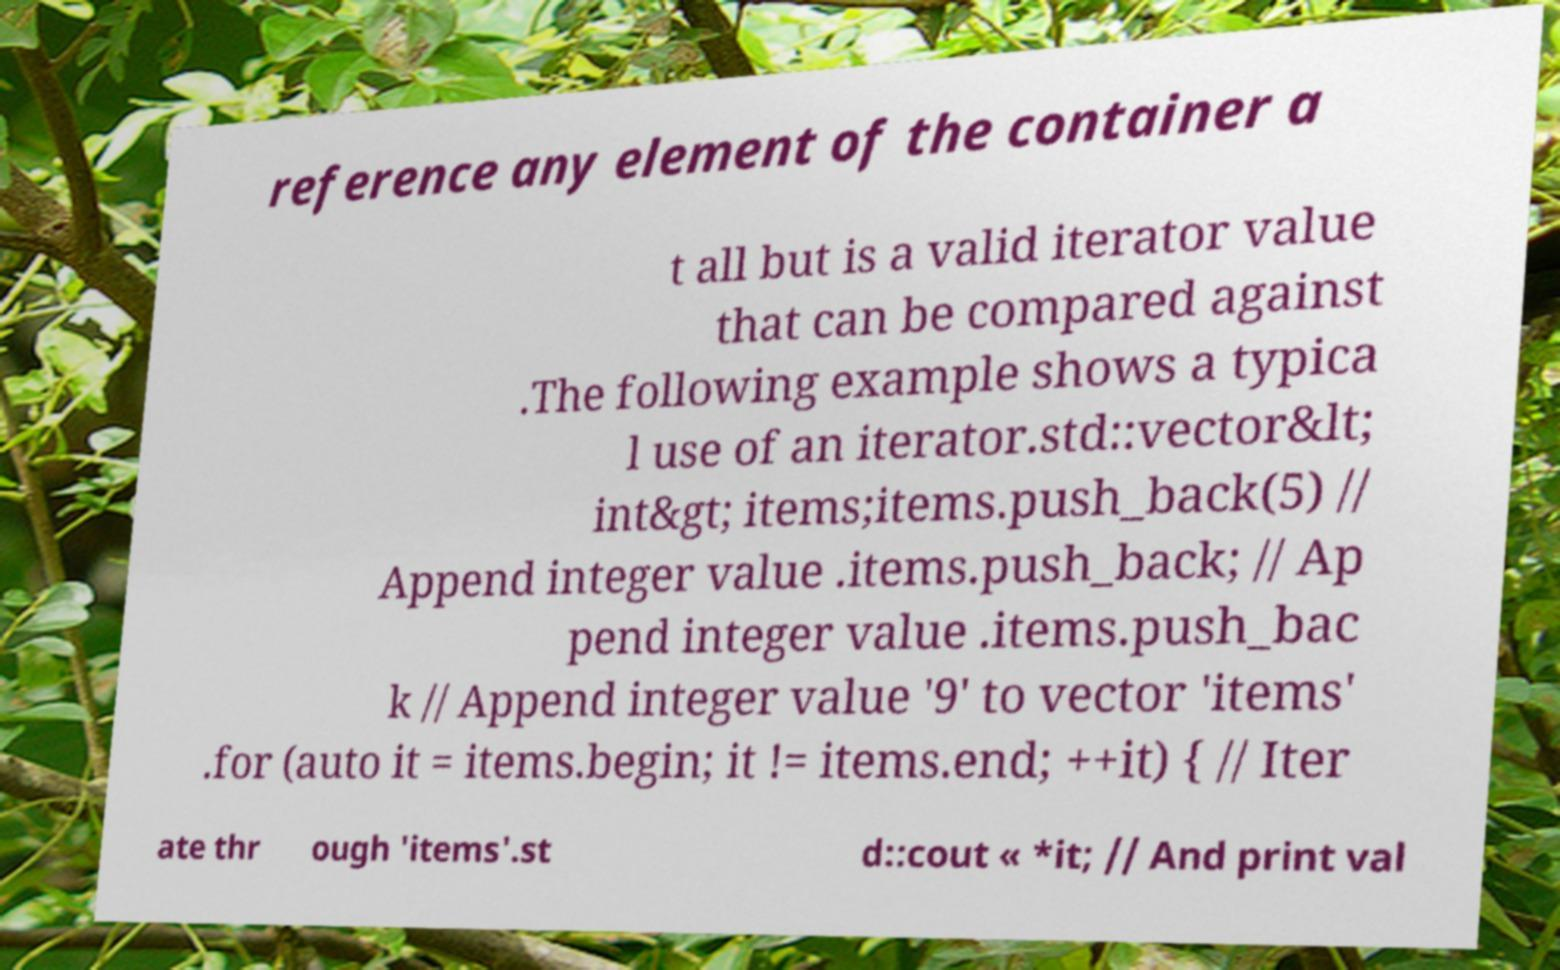Could you assist in decoding the text presented in this image and type it out clearly? reference any element of the container a t all but is a valid iterator value that can be compared against .The following example shows a typica l use of an iterator.std::vector&lt; int&gt; items;items.push_back(5) // Append integer value .items.push_back; // Ap pend integer value .items.push_bac k // Append integer value '9' to vector 'items' .for (auto it = items.begin; it != items.end; ++it) { // Iter ate thr ough 'items'.st d::cout « *it; // And print val 